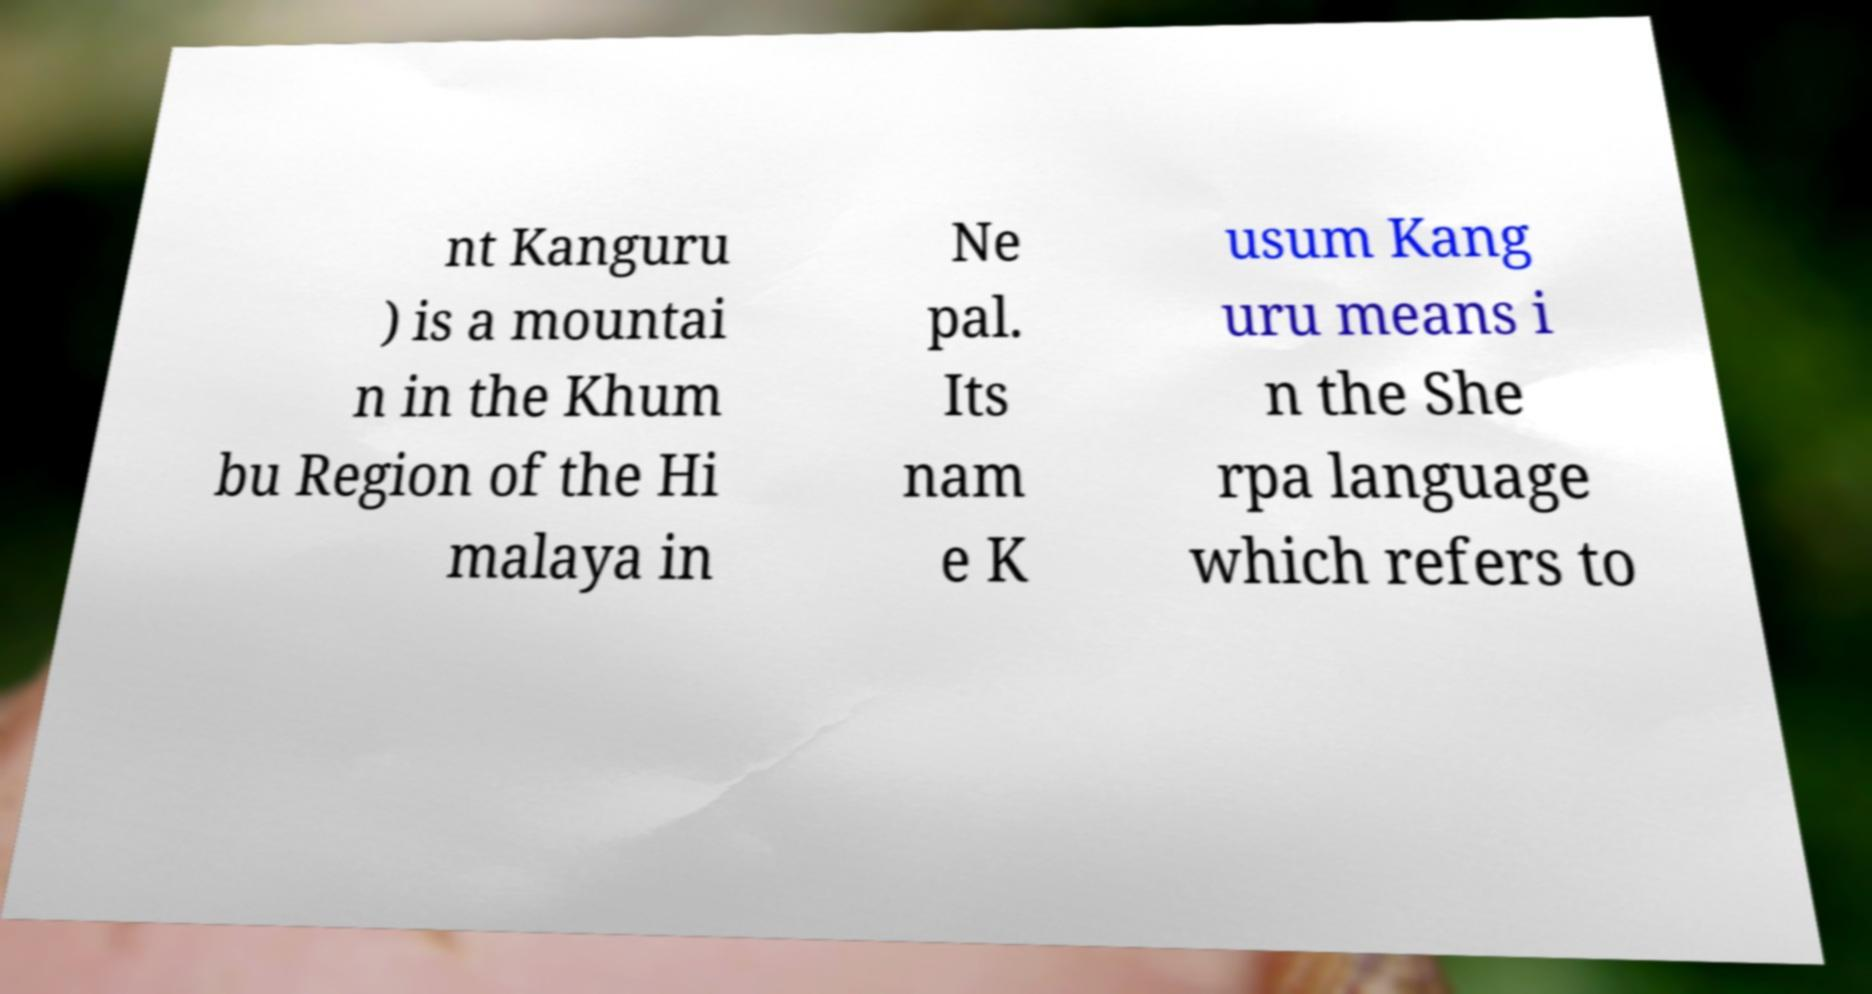What messages or text are displayed in this image? I need them in a readable, typed format. nt Kanguru ) is a mountai n in the Khum bu Region of the Hi malaya in Ne pal. Its nam e K usum Kang uru means i n the She rpa language which refers to 